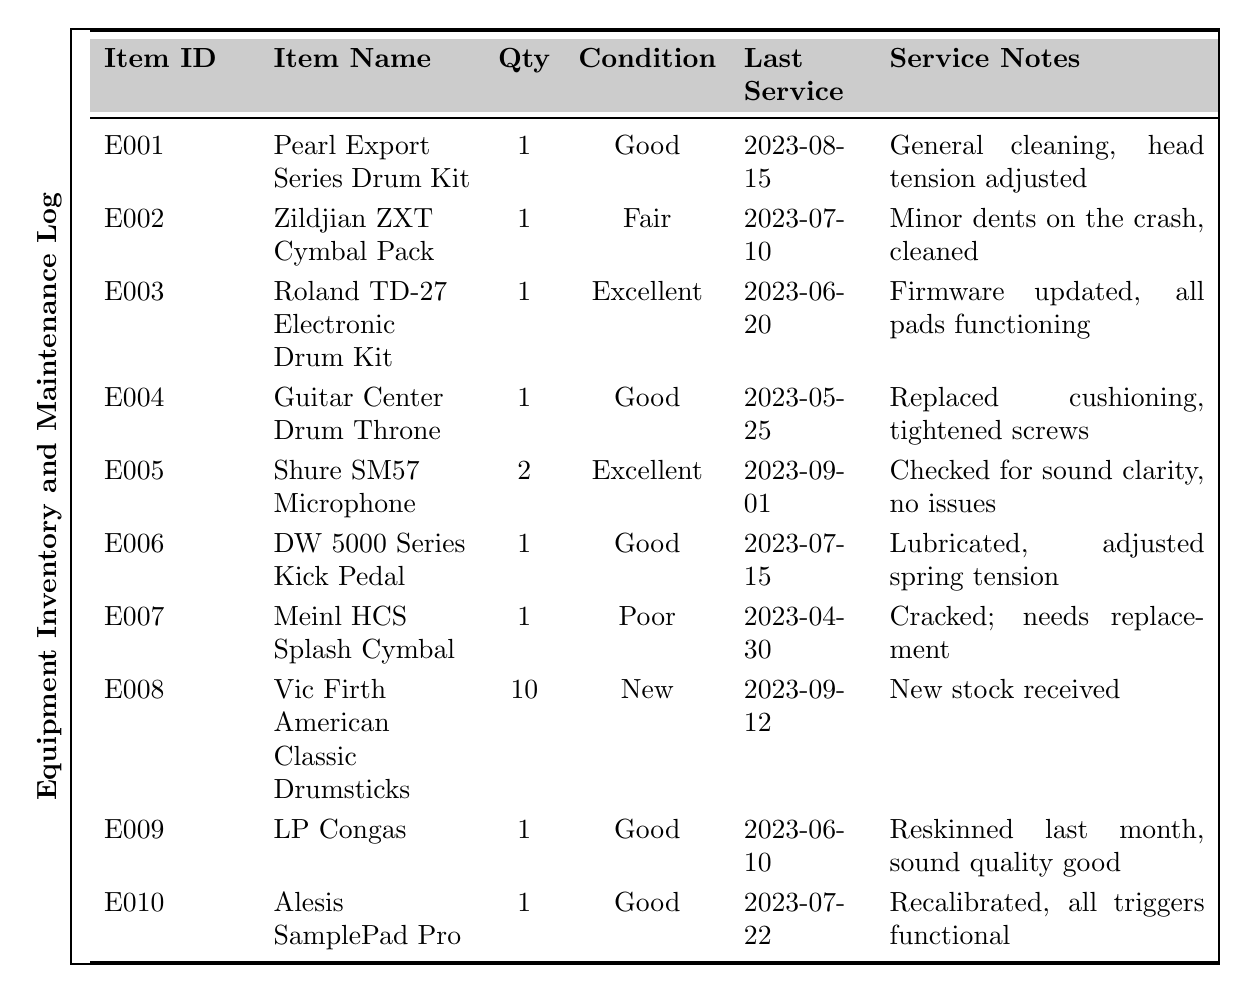What is the condition of the Meinl HCS Splash Cymbal? Referring to the table, the condition of the Meinl HCS Splash Cymbal (Item ID: E007) is listed as "Poor."
Answer: Poor How many pieces of equipment are in excellent condition? Looking through the table, there are two items listed as being in excellent condition: the Roland TD-27 Electronic Drum Kit (E003) and the Shure SM57 Microphone (E005).
Answer: 2 What was the last service date for the Guitar Center Drum Throne? The table indicates that the last service date for the Guitar Center Drum Throne (Item ID: E004) was on "2023-05-25."
Answer: 2023-05-25 Which item has the most recent service date? Analyzing the last service dates in the table, the most recent service date is for the Shure SM57 Microphone (E005) on "2023-09-01."
Answer: Shure SM57 Microphone What is the total quantity of drumsticks available? The table shows there are 10 Vic Firth American Classic Drumsticks (E008) listed, and it’s the only type of drumsticks mentioned, so the total quantity is 10.
Answer: 10 Which piece of equipment needs replacement? The table indicates that the Meinl HCS Splash Cymbal (E007) is cracked and needs replacement, which is noted in the service notes.
Answer: Meinl HCS Splash Cymbal How many items are in good condition? By reviewing the table, there are four items listed as being in good condition: Pearl Export Series Drum Kit (E001), Guitar Center Drum Throne (E004), DW 5000 Series Kick Pedal (E006), and Alesis SamplePad Pro (E010).
Answer: 4 Is the Shure SM57 Microphone in fair condition? The table lists the Shure SM57 Microphone (E005) as being in "Excellent" condition, not fair.
Answer: No What was done during the last service of the Roland TD-27 Electronic Drum Kit? The service notes for the Roland TD-27 Electronic Drum Kit (E003) mention that the firmware was updated and all pads are functioning properly.
Answer: Firmware updated, all pads functioning Which item requires the least amount of quantity to be replaced or serviced? The Meinl HCS Splash Cymbal (E007), listed with a quantity of 1 and noted as cracked and needing replacement, requires immediate attention, making it the least in terms of quantity requiring replacement or servicing.
Answer: Meinl HCS Splash Cymbal What is the average condition rating of the equipment inventory, considering each category as follows: Excellent (3), Good (2), Fair (1), and Poor (0)? The equipment count includes 1 Excellent (E003), 4 Good (E001, E004, E006, E010), 1 Fair (E002), and 1 Poor (E007), calculating the average gives (3 + 2*4 + 1 + 0) / 7 = 1.571.
Answer: 1.57 